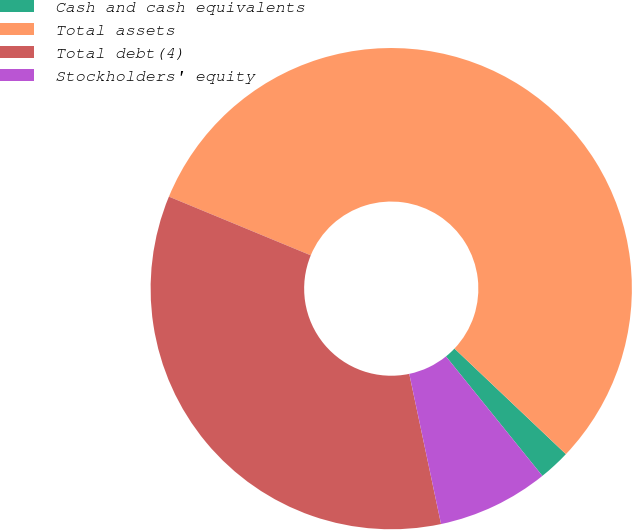Convert chart. <chart><loc_0><loc_0><loc_500><loc_500><pie_chart><fcel>Cash and cash equivalents<fcel>Total assets<fcel>Total debt(4)<fcel>Stockholders' equity<nl><fcel>2.12%<fcel>55.82%<fcel>34.56%<fcel>7.49%<nl></chart> 